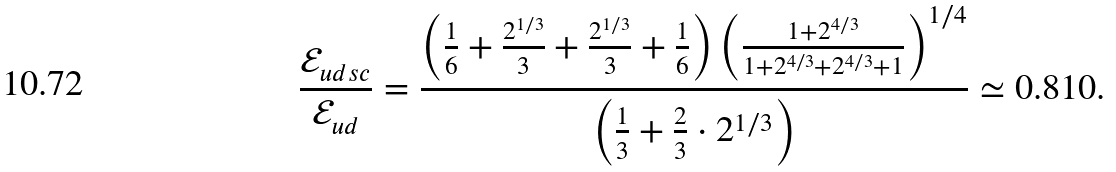<formula> <loc_0><loc_0><loc_500><loc_500>\frac { \mathcal { E } _ { u d s c } } { \mathcal { E } _ { u d } } = \frac { \left ( \frac { 1 } { 6 } + \frac { 2 ^ { 1 / 3 } } { 3 } + \frac { 2 ^ { 1 / 3 } } { 3 } + \frac { 1 } { 6 } \right ) \left ( \frac { 1 + 2 ^ { 4 / 3 } } { 1 + 2 ^ { 4 / 3 } + 2 ^ { 4 / 3 } + 1 } \right ) ^ { 1 / 4 } } { \left ( \frac { 1 } { 3 } + \frac { 2 } { 3 } \cdot 2 ^ { 1 / 3 } \right ) } \simeq 0 . 8 1 0 .</formula> 